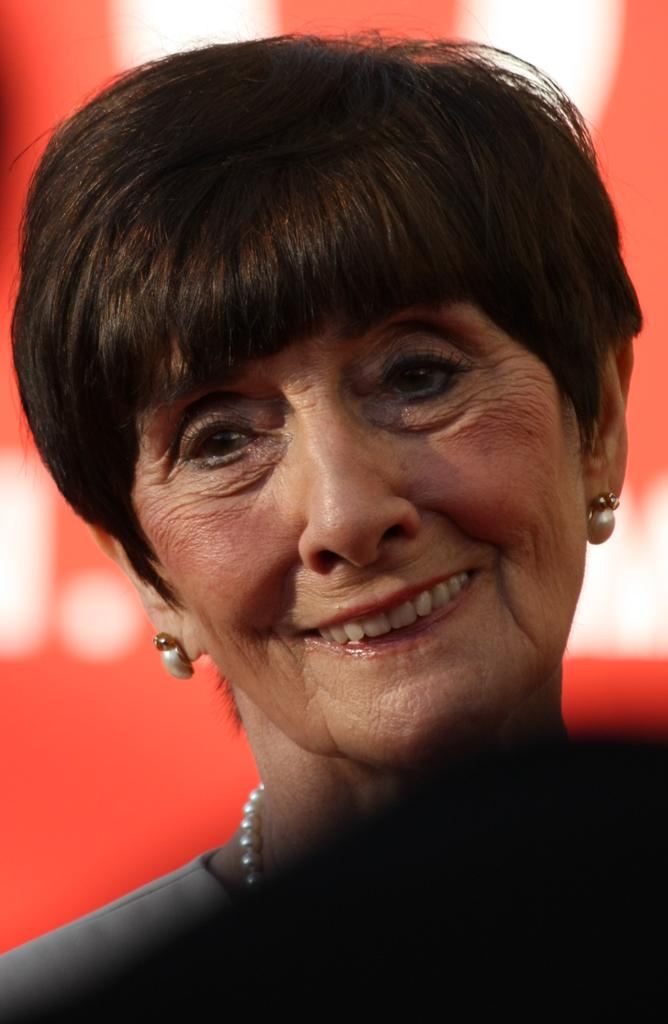Who is the main subject in the image? There is a lady in the center of the image. What type of scent can be detected from the lady in the image? There is no information about any scent associated with the lady in the image, so we cannot answer this question. 